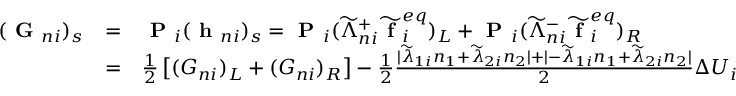<formula> <loc_0><loc_0><loc_500><loc_500>\begin{array} { r } { \begin{array} { l c l } { ( G _ { n i } ) _ { s } } & { = } & { P _ { i } ( h _ { n i } ) _ { s } = P _ { i } ( \widetilde { \Lambda } _ { n i } ^ { + } \widetilde { f } _ { i } ^ { e q } ) _ { L } + P _ { i } ( \widetilde { \Lambda } _ { n i } ^ { - } \widetilde { f } _ { i } ^ { e q } ) _ { R } } \\ & { = } & { \frac { 1 } { 2 } \left [ ( G _ { n i } ) _ { L } + ( G _ { n i } ) _ { R } \right ] - \frac { 1 } { 2 } \frac { | \widetilde { \lambda } _ { 1 i } n _ { 1 } + \widetilde { \lambda } _ { 2 i } n _ { 2 } | + | - \widetilde { \lambda } _ { 1 i } n _ { 1 } + \widetilde { \lambda } _ { 2 i } n _ { 2 } | } { 2 } \Delta U _ { i } } \end{array} } \end{array}</formula> 